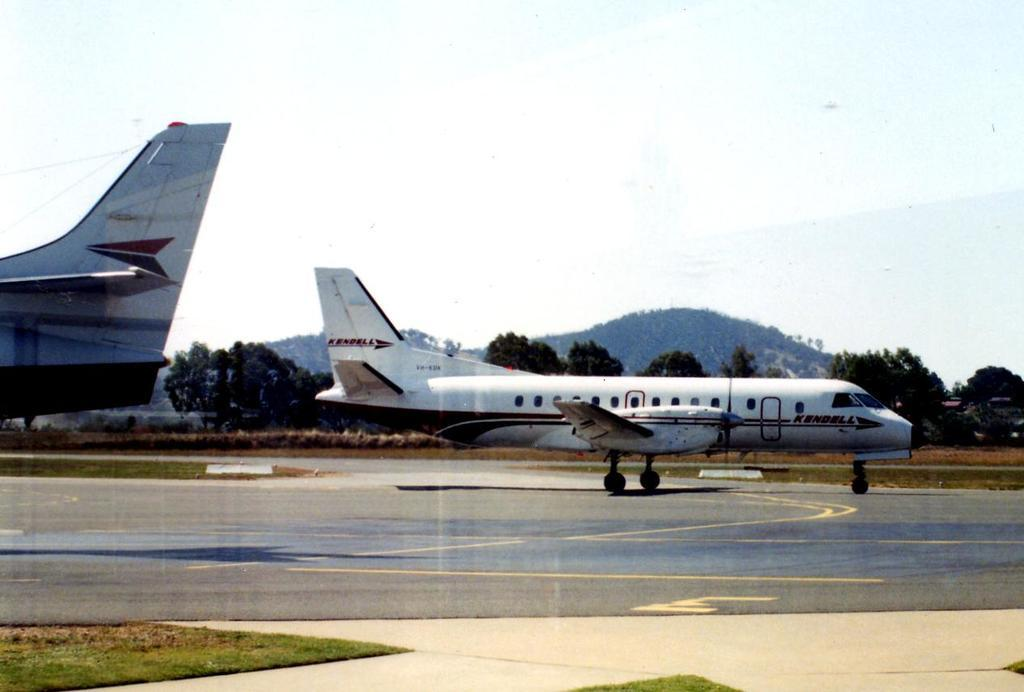<image>
Provide a brief description of the given image. On the tarmat with large jets and the medium size Kendell jet taking off. 